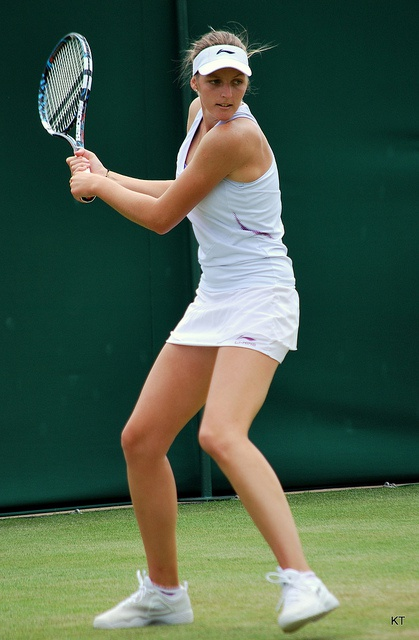Describe the objects in this image and their specific colors. I can see people in black, lightgray, brown, and tan tones and tennis racket in black, lightgray, darkgray, and gray tones in this image. 